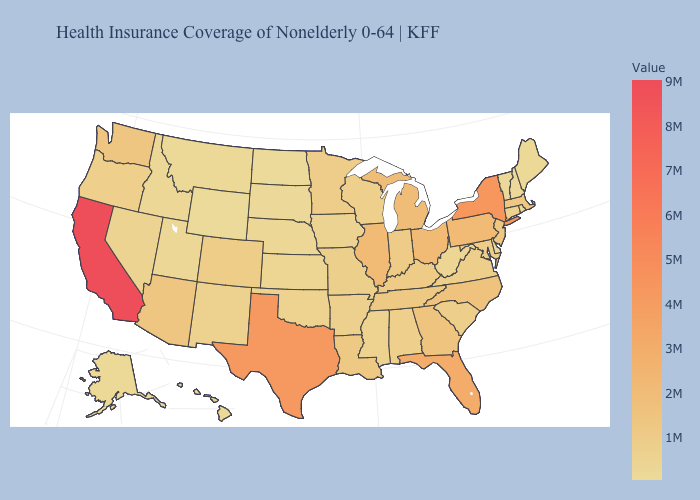Which states have the lowest value in the MidWest?
Concise answer only. North Dakota. Does Delaware have the lowest value in the South?
Keep it brief. Yes. Among the states that border Missouri , which have the lowest value?
Answer briefly. Nebraska. Does New York have the highest value in the Northeast?
Give a very brief answer. Yes. Which states hav the highest value in the Northeast?
Be succinct. New York. 